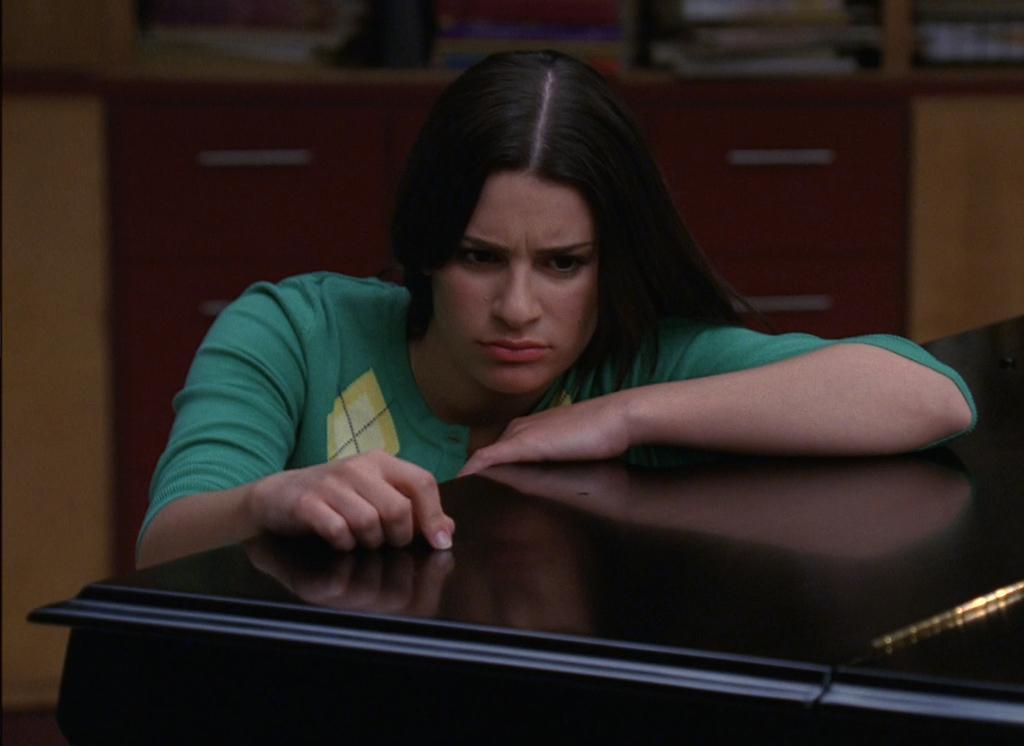Can you describe this image briefly? In this image I can see a woman beside the table and she is looking at the table. In the background I can see a cupboard and there are some books are placed in it. 